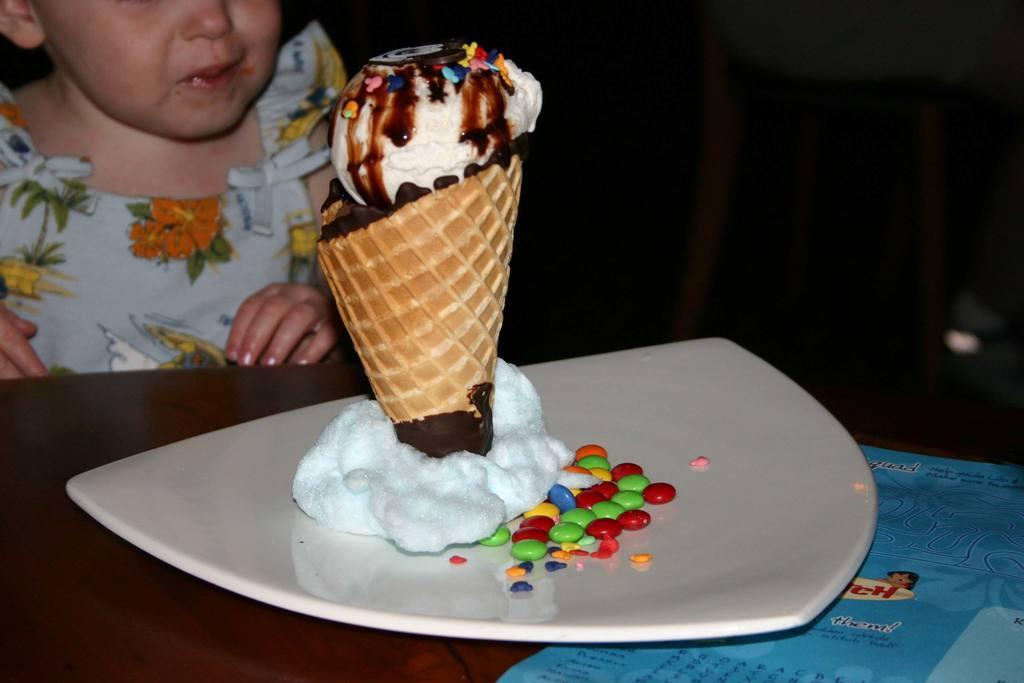How would you summarize this image in a sentence or two? In this picture we can see a kid in front of a table, there is a paper and a plate present on the table, we can see gems and an ice cream present in the plate. 